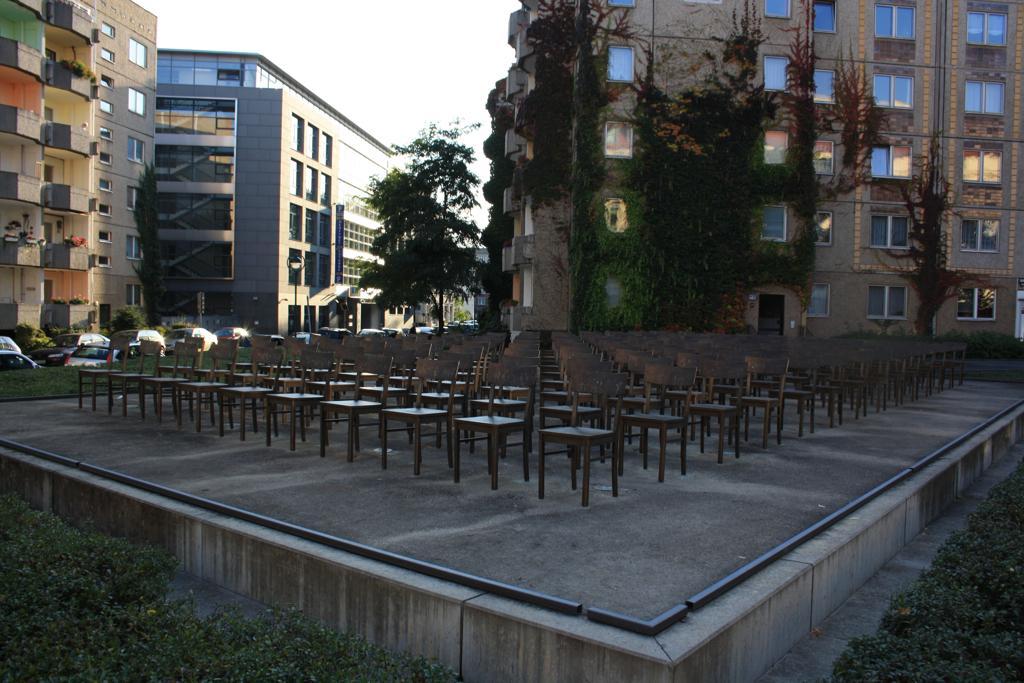Could you give a brief overview of what you see in this image? In this image we can see a group of chairs placed in an order on the surface. We can also see some plants. On the backside we can see some buildings with windows, a group of vehicles parked aside, some plants, trees and the sky which looks cloudy. 